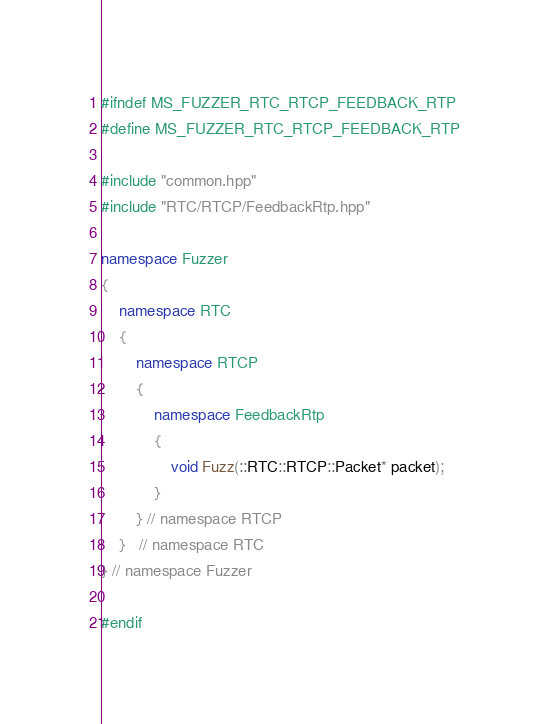<code> <loc_0><loc_0><loc_500><loc_500><_C++_>#ifndef MS_FUZZER_RTC_RTCP_FEEDBACK_RTP
#define MS_FUZZER_RTC_RTCP_FEEDBACK_RTP

#include "common.hpp"
#include "RTC/RTCP/FeedbackRtp.hpp"

namespace Fuzzer
{
	namespace RTC
	{
		namespace RTCP
		{
			namespace FeedbackRtp
			{
				void Fuzz(::RTC::RTCP::Packet* packet);
			}
		} // namespace RTCP
	}   // namespace RTC
} // namespace Fuzzer

#endif
</code> 